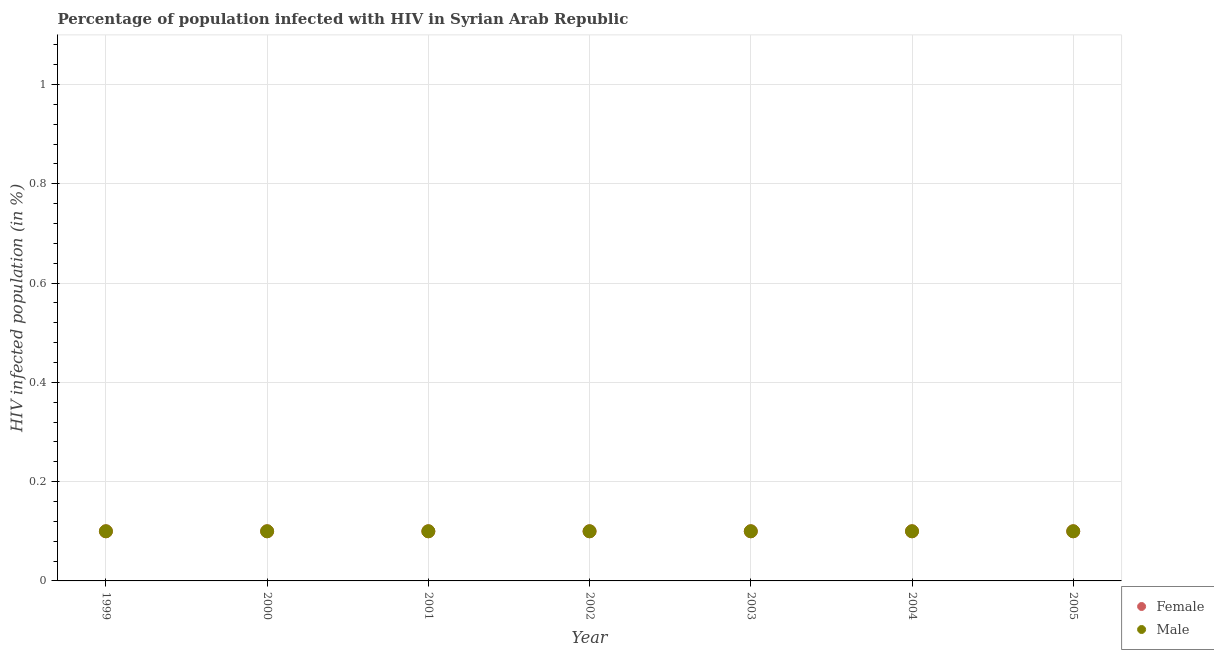How many different coloured dotlines are there?
Ensure brevity in your answer.  2. Across all years, what is the minimum percentage of males who are infected with hiv?
Give a very brief answer. 0.1. In which year was the percentage of females who are infected with hiv minimum?
Make the answer very short. 1999. What is the total percentage of females who are infected with hiv in the graph?
Make the answer very short. 0.7. What is the difference between the percentage of males who are infected with hiv in 2000 and that in 2001?
Provide a succinct answer. 0. What is the average percentage of males who are infected with hiv per year?
Provide a succinct answer. 0.1. In the year 2005, what is the difference between the percentage of females who are infected with hiv and percentage of males who are infected with hiv?
Your answer should be compact. 0. What is the ratio of the percentage of males who are infected with hiv in 2001 to that in 2002?
Ensure brevity in your answer.  1. Is the percentage of females who are infected with hiv in 1999 less than that in 2000?
Provide a succinct answer. No. Does the percentage of females who are infected with hiv monotonically increase over the years?
Your response must be concise. No. Is the percentage of males who are infected with hiv strictly greater than the percentage of females who are infected with hiv over the years?
Your answer should be very brief. No. How many dotlines are there?
Give a very brief answer. 2. What is the difference between two consecutive major ticks on the Y-axis?
Ensure brevity in your answer.  0.2. Are the values on the major ticks of Y-axis written in scientific E-notation?
Give a very brief answer. No. Does the graph contain any zero values?
Your response must be concise. No. What is the title of the graph?
Your response must be concise. Percentage of population infected with HIV in Syrian Arab Republic. What is the label or title of the Y-axis?
Offer a very short reply. HIV infected population (in %). What is the HIV infected population (in %) of Female in 1999?
Give a very brief answer. 0.1. What is the HIV infected population (in %) in Male in 1999?
Your answer should be compact. 0.1. What is the HIV infected population (in %) of Female in 2000?
Keep it short and to the point. 0.1. What is the HIV infected population (in %) of Female in 2002?
Keep it short and to the point. 0.1. What is the HIV infected population (in %) in Female in 2003?
Give a very brief answer. 0.1. What is the HIV infected population (in %) in Female in 2004?
Keep it short and to the point. 0.1. What is the HIV infected population (in %) in Male in 2004?
Ensure brevity in your answer.  0.1. What is the HIV infected population (in %) of Female in 2005?
Offer a very short reply. 0.1. Across all years, what is the maximum HIV infected population (in %) of Male?
Provide a short and direct response. 0.1. Across all years, what is the minimum HIV infected population (in %) of Male?
Ensure brevity in your answer.  0.1. What is the total HIV infected population (in %) in Female in the graph?
Offer a very short reply. 0.7. What is the difference between the HIV infected population (in %) of Female in 1999 and that in 2000?
Make the answer very short. 0. What is the difference between the HIV infected population (in %) in Male in 1999 and that in 2001?
Offer a terse response. 0. What is the difference between the HIV infected population (in %) of Female in 1999 and that in 2002?
Offer a very short reply. 0. What is the difference between the HIV infected population (in %) in Male in 1999 and that in 2002?
Offer a terse response. 0. What is the difference between the HIV infected population (in %) of Female in 1999 and that in 2003?
Provide a succinct answer. 0. What is the difference between the HIV infected population (in %) of Male in 1999 and that in 2003?
Offer a terse response. 0. What is the difference between the HIV infected population (in %) in Female in 1999 and that in 2004?
Ensure brevity in your answer.  0. What is the difference between the HIV infected population (in %) of Male in 1999 and that in 2005?
Provide a succinct answer. 0. What is the difference between the HIV infected population (in %) in Female in 2000 and that in 2003?
Ensure brevity in your answer.  0. What is the difference between the HIV infected population (in %) of Male in 2000 and that in 2003?
Keep it short and to the point. 0. What is the difference between the HIV infected population (in %) of Male in 2000 and that in 2005?
Offer a terse response. 0. What is the difference between the HIV infected population (in %) in Female in 2001 and that in 2004?
Ensure brevity in your answer.  0. What is the difference between the HIV infected population (in %) of Male in 2001 and that in 2004?
Keep it short and to the point. 0. What is the difference between the HIV infected population (in %) in Female in 2002 and that in 2003?
Your response must be concise. 0. What is the difference between the HIV infected population (in %) in Female in 2002 and that in 2004?
Your answer should be compact. 0. What is the difference between the HIV infected population (in %) of Male in 2002 and that in 2005?
Your response must be concise. 0. What is the difference between the HIV infected population (in %) of Female in 2003 and that in 2004?
Give a very brief answer. 0. What is the difference between the HIV infected population (in %) in Male in 2003 and that in 2004?
Provide a succinct answer. 0. What is the difference between the HIV infected population (in %) of Female in 2003 and that in 2005?
Ensure brevity in your answer.  0. What is the difference between the HIV infected population (in %) in Male in 2003 and that in 2005?
Provide a succinct answer. 0. What is the difference between the HIV infected population (in %) of Female in 1999 and the HIV infected population (in %) of Male in 2000?
Ensure brevity in your answer.  0. What is the difference between the HIV infected population (in %) in Female in 1999 and the HIV infected population (in %) in Male in 2001?
Keep it short and to the point. 0. What is the difference between the HIV infected population (in %) in Female in 2000 and the HIV infected population (in %) in Male in 2001?
Offer a terse response. 0. What is the difference between the HIV infected population (in %) of Female in 2000 and the HIV infected population (in %) of Male in 2002?
Keep it short and to the point. 0. What is the difference between the HIV infected population (in %) in Female in 2000 and the HIV infected population (in %) in Male in 2003?
Ensure brevity in your answer.  0. What is the difference between the HIV infected population (in %) of Female in 2000 and the HIV infected population (in %) of Male in 2004?
Offer a very short reply. 0. What is the difference between the HIV infected population (in %) in Female in 2001 and the HIV infected population (in %) in Male in 2002?
Your response must be concise. 0. What is the difference between the HIV infected population (in %) of Female in 2001 and the HIV infected population (in %) of Male in 2004?
Give a very brief answer. 0. What is the difference between the HIV infected population (in %) in Female in 2003 and the HIV infected population (in %) in Male in 2004?
Keep it short and to the point. 0. What is the difference between the HIV infected population (in %) of Female in 2004 and the HIV infected population (in %) of Male in 2005?
Give a very brief answer. 0. What is the average HIV infected population (in %) in Female per year?
Offer a very short reply. 0.1. What is the average HIV infected population (in %) of Male per year?
Your answer should be very brief. 0.1. In the year 2000, what is the difference between the HIV infected population (in %) in Female and HIV infected population (in %) in Male?
Provide a short and direct response. 0. What is the ratio of the HIV infected population (in %) of Female in 1999 to that in 2001?
Your answer should be compact. 1. What is the ratio of the HIV infected population (in %) of Female in 1999 to that in 2002?
Make the answer very short. 1. What is the ratio of the HIV infected population (in %) in Male in 1999 to that in 2002?
Offer a very short reply. 1. What is the ratio of the HIV infected population (in %) of Male in 1999 to that in 2003?
Keep it short and to the point. 1. What is the ratio of the HIV infected population (in %) of Female in 2000 to that in 2001?
Your response must be concise. 1. What is the ratio of the HIV infected population (in %) in Male in 2000 to that in 2001?
Provide a succinct answer. 1. What is the ratio of the HIV infected population (in %) of Female in 2000 to that in 2002?
Keep it short and to the point. 1. What is the ratio of the HIV infected population (in %) in Male in 2000 to that in 2004?
Offer a very short reply. 1. What is the ratio of the HIV infected population (in %) in Female in 2000 to that in 2005?
Give a very brief answer. 1. What is the ratio of the HIV infected population (in %) in Male in 2001 to that in 2004?
Ensure brevity in your answer.  1. What is the ratio of the HIV infected population (in %) of Male in 2001 to that in 2005?
Your answer should be compact. 1. What is the ratio of the HIV infected population (in %) of Male in 2002 to that in 2003?
Keep it short and to the point. 1. What is the ratio of the HIV infected population (in %) in Female in 2002 to that in 2004?
Your answer should be very brief. 1. What is the ratio of the HIV infected population (in %) in Male in 2002 to that in 2004?
Provide a short and direct response. 1. What is the ratio of the HIV infected population (in %) of Male in 2002 to that in 2005?
Make the answer very short. 1. What is the ratio of the HIV infected population (in %) of Female in 2003 to that in 2004?
Ensure brevity in your answer.  1. What is the ratio of the HIV infected population (in %) in Male in 2003 to that in 2004?
Make the answer very short. 1. What is the ratio of the HIV infected population (in %) in Female in 2003 to that in 2005?
Your response must be concise. 1. What is the ratio of the HIV infected population (in %) in Male in 2004 to that in 2005?
Provide a succinct answer. 1. 